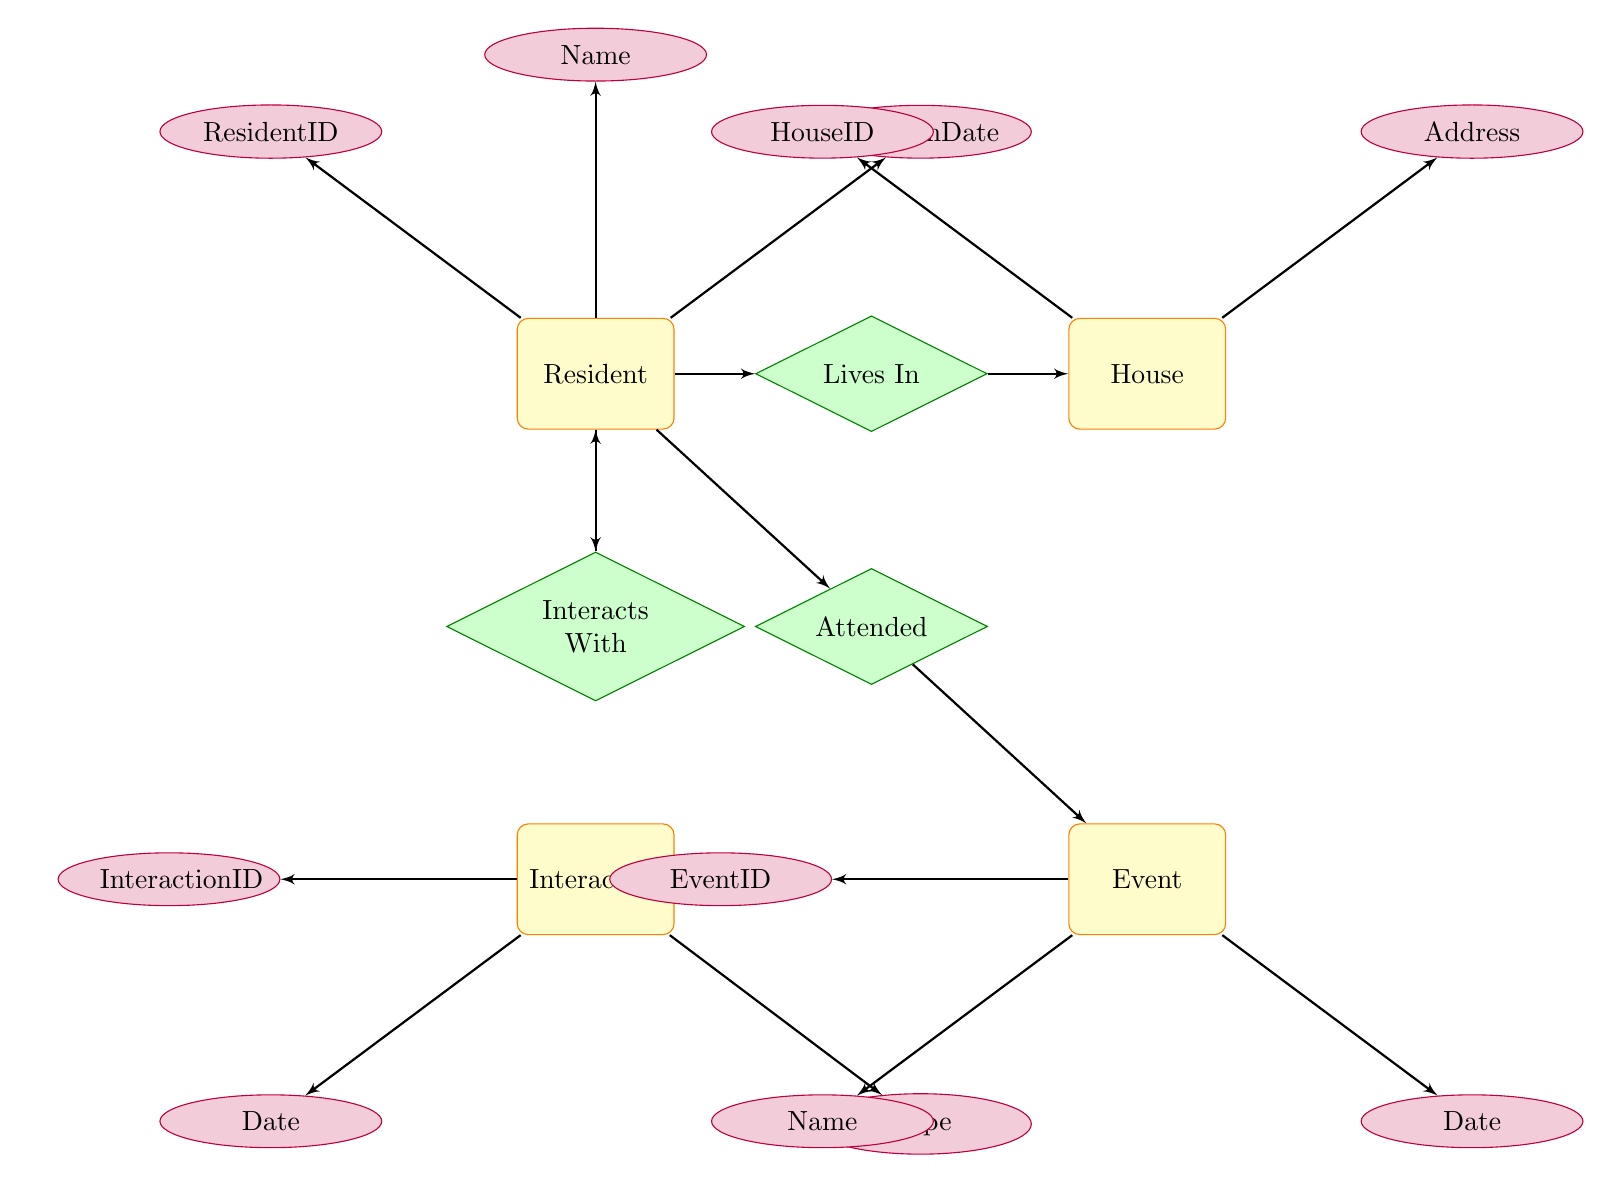What is the primary relationship involving the Resident entity? The primary relationship involving the Resident entity is "Lives In," which connects it to the House entity. This indicates where each resident lives.
Answer: Lives In How many attributes does the Event entity have? The Event entity has three attributes: EventID, Name, and Date. By counting these attributes, we find the total is three.
Answer: 3 What is the relationship type between two Resident entities? The relationship type between two Resident entities is "Interacts With." This connection is specific to how residents communicate or interact with each other.
Answer: Interacts With Name one type of attribute associated with the Interaction entity. One type of attribute associated with the Interaction entity is "InteractionID." This attribute uniquely identifies each interaction instance between residents.
Answer: InteractionID What is the connection between a Resident and an Event? The connection between a Resident and an Event is established through the "Attended" relationship, which shows which events residents participate in.
Answer: Attended How many different entities are represented in the diagram? The diagram represents four different entities: Resident, House, Interaction, and Event. Counting the distinct types gives a total of four.
Answer: 4 Which entity is associated with the "Address" attribute? The "Address" attribute is associated with the House entity. This indicates the specific location where the house resides.
Answer: House What does the Interaction entity represent in terms of relationships? The Interaction entity represents social relationships among Residents through the "Interacts With" relationship. This shows social dynamics in the community.
Answer: Interacts With Which entity includes the "MoveInDate" attribute? The "MoveInDate" attribute is included in the Resident entity. It specifies when each resident moved into their residence.
Answer: Resident 